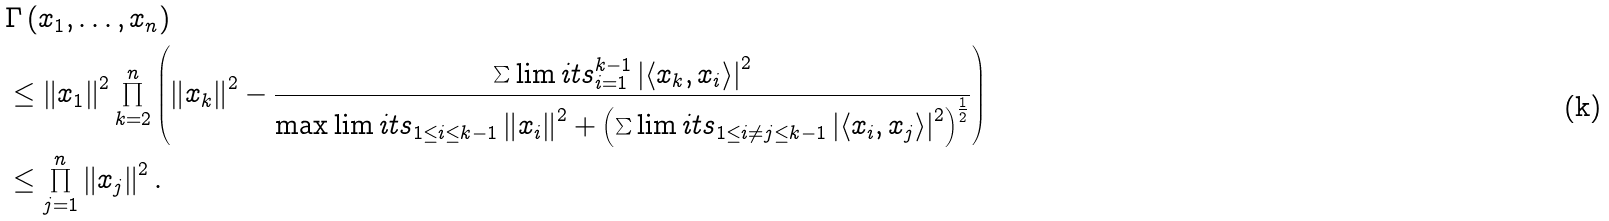<formula> <loc_0><loc_0><loc_500><loc_500>& \Gamma \left ( x _ { 1 } , \dots , x _ { n } \right ) \\ & \leq \left \| x _ { 1 } \right \| ^ { 2 } \prod _ { k = 2 } ^ { n } \left ( \left \| x _ { k } \right \| ^ { 2 } - \frac { \sum \lim i t s _ { i = 1 } ^ { k - 1 } \left | \left \langle x _ { k } , x _ { i } \right \rangle \right | ^ { 2 } } { \max \lim i t s _ { 1 \leq i \leq k - 1 } \left \| x _ { i } \right \| ^ { 2 } + \left ( \sum \lim i t s _ { 1 \leq i \neq j \leq k - 1 } \left | \left \langle x _ { i } , x _ { j } \right \rangle \right | ^ { 2 } \right ) ^ { \frac { 1 } { 2 } } } \right ) \\ & \leq \prod _ { j = 1 } ^ { n } \left \| x _ { j } \right \| ^ { 2 } .</formula> 